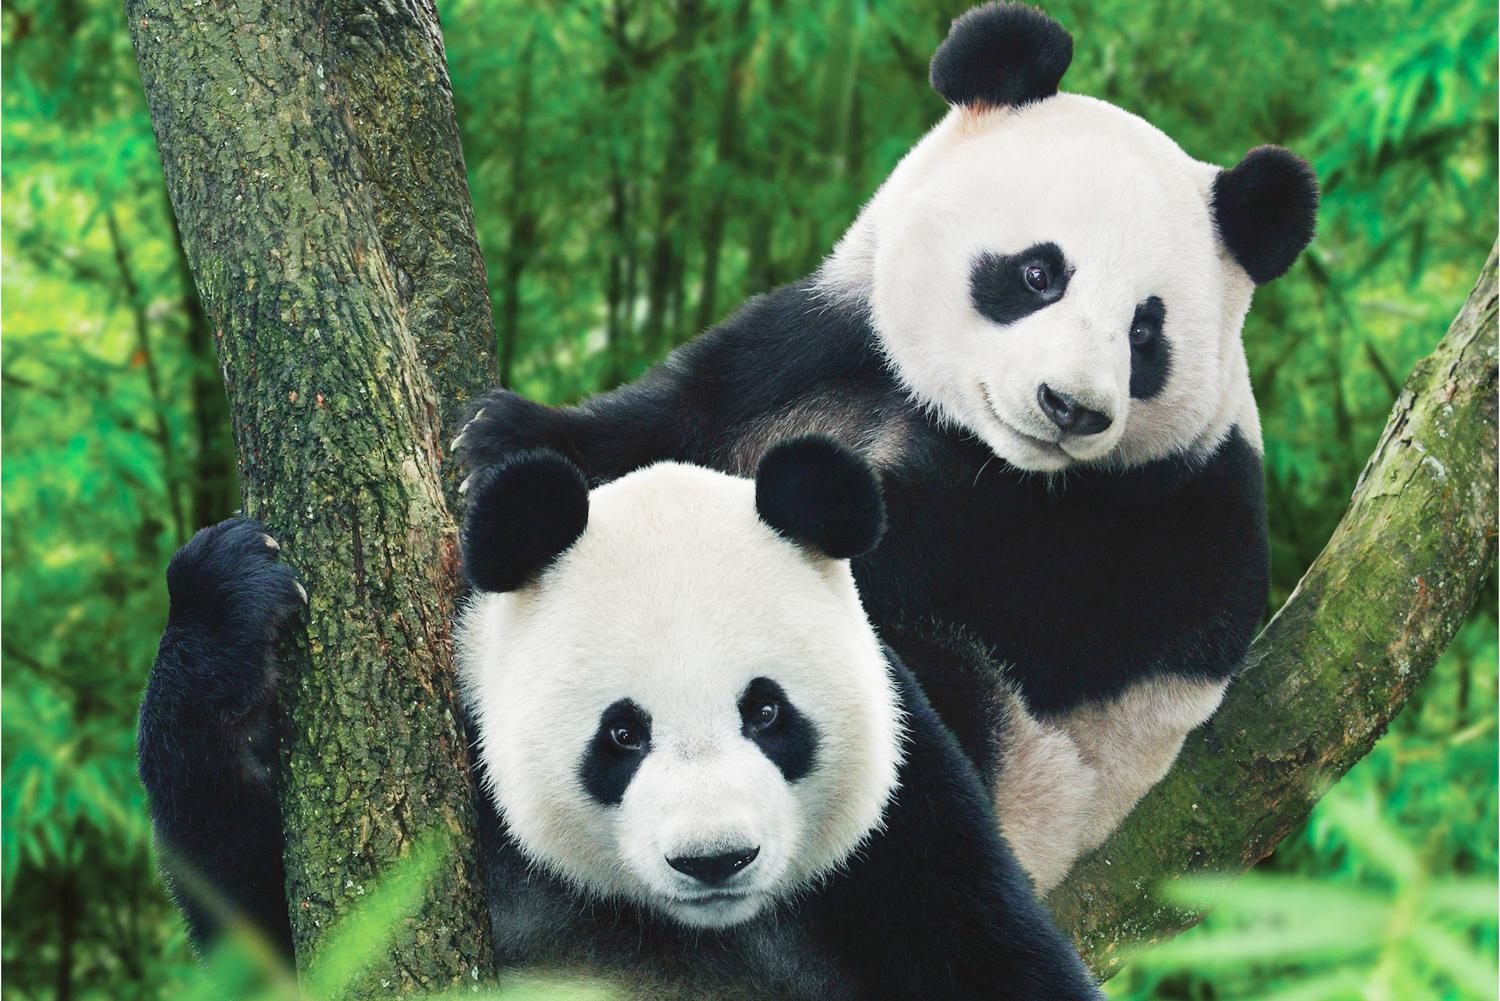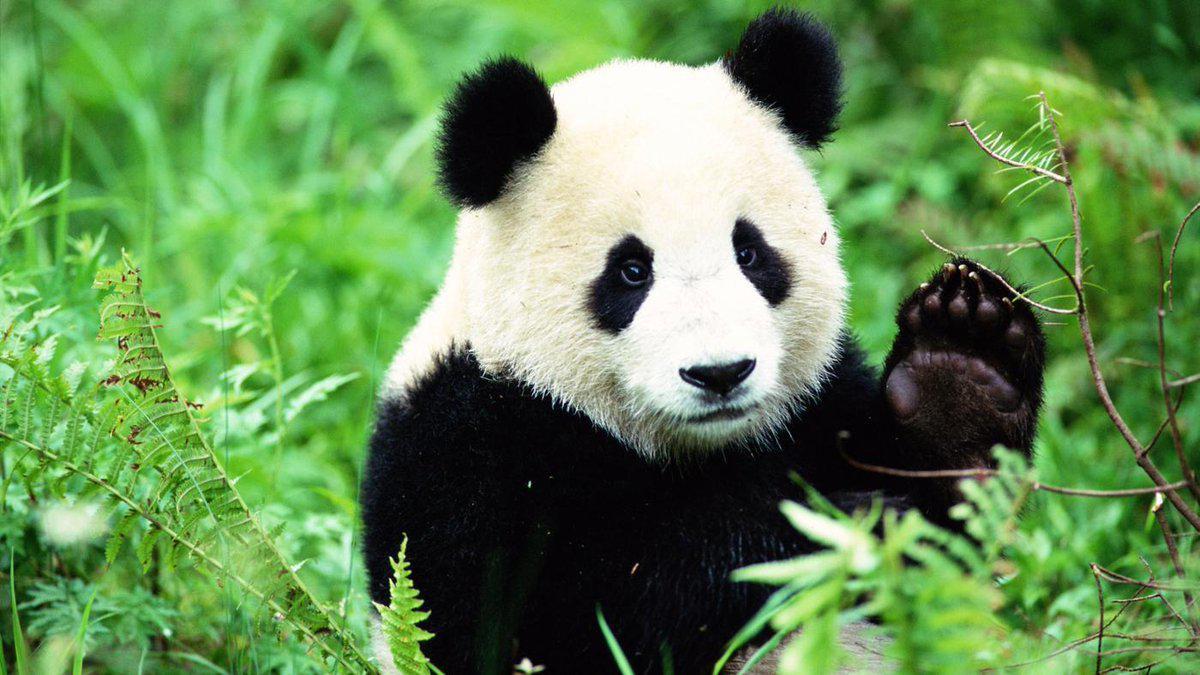The first image is the image on the left, the second image is the image on the right. Analyze the images presented: Is the assertion "At least one of the pandas is lying down." valid? Answer yes or no. No. The first image is the image on the left, the second image is the image on the right. Considering the images on both sides, is "In one image, a panda is lying back with its mouth open and tongue showing." valid? Answer yes or no. No. 